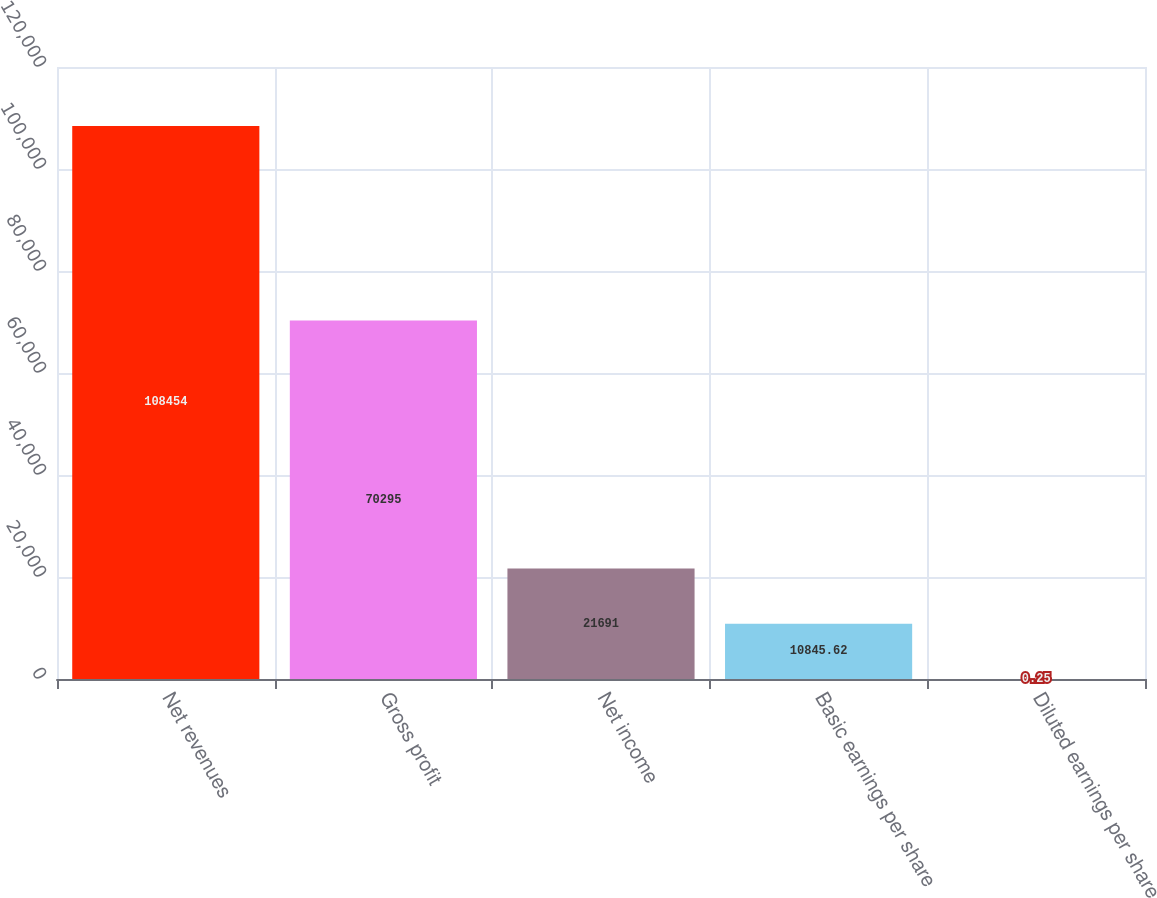Convert chart to OTSL. <chart><loc_0><loc_0><loc_500><loc_500><bar_chart><fcel>Net revenues<fcel>Gross profit<fcel>Net income<fcel>Basic earnings per share<fcel>Diluted earnings per share<nl><fcel>108454<fcel>70295<fcel>21691<fcel>10845.6<fcel>0.25<nl></chart> 